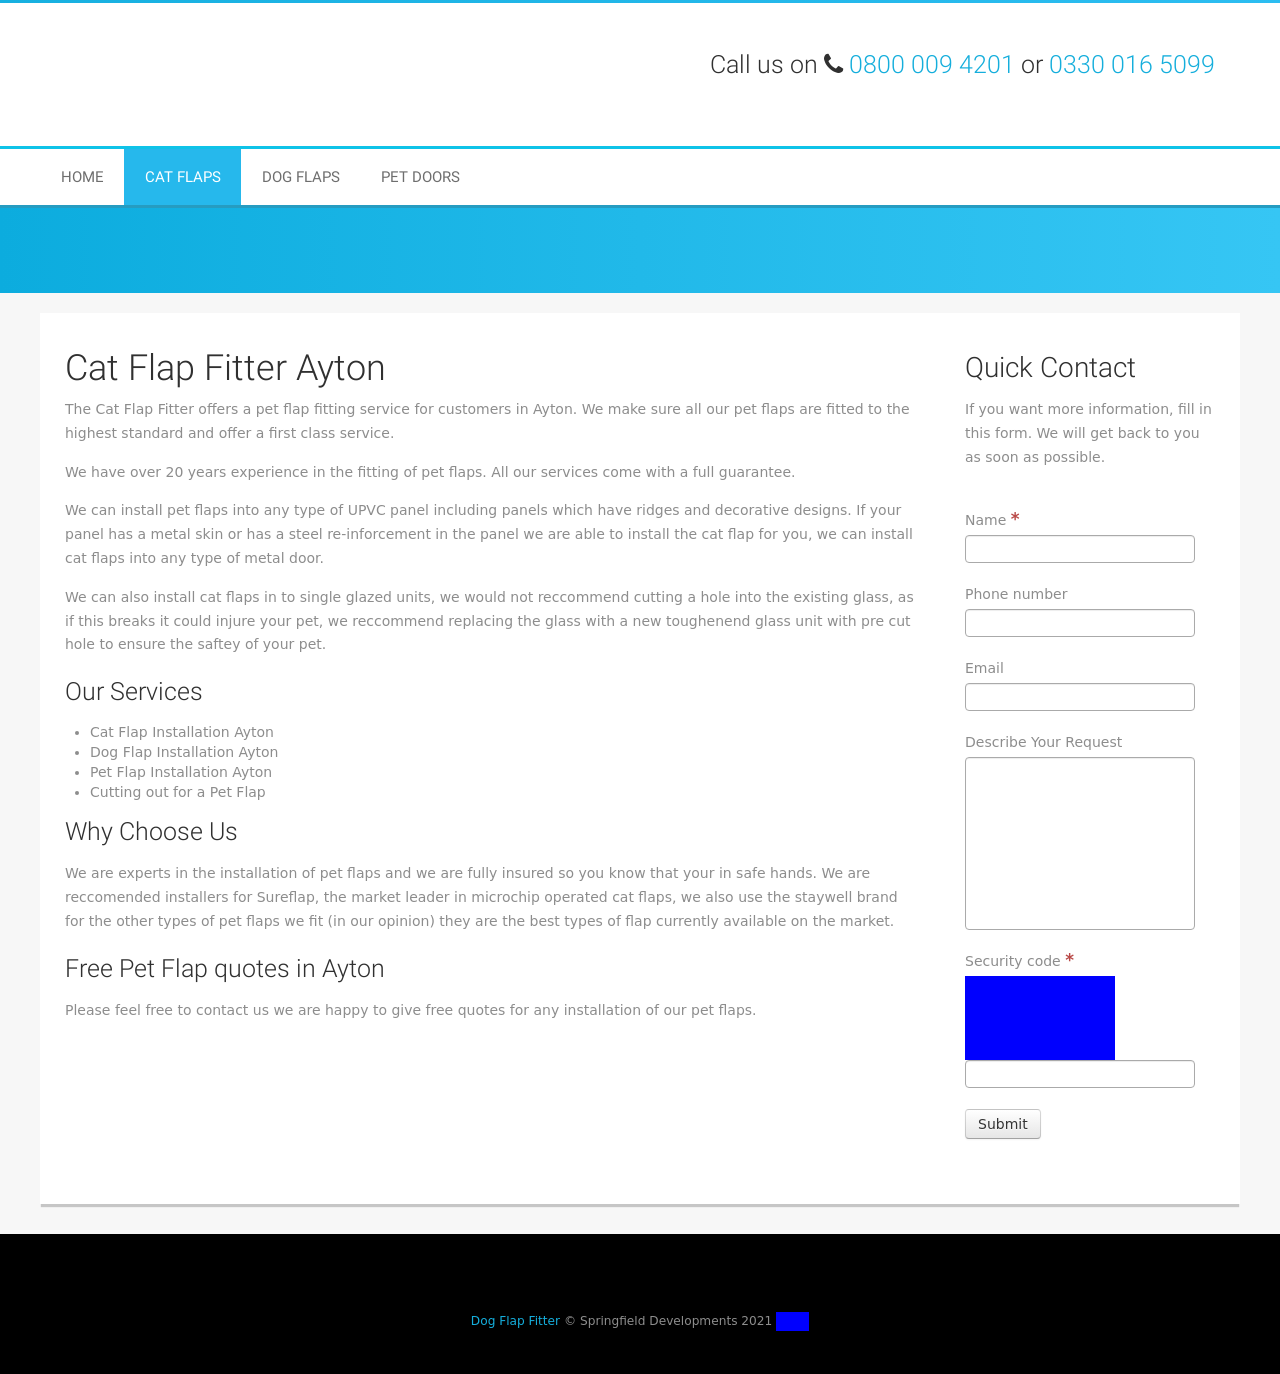Can you explain why using toughened glass is recommended for pet flap installations? Using toughened glass for pet flap installations is recommended because it enhances safety. Cutting holes in existing glass can weaken it and risk breakage, which could potentially harm the pet. Toughened glass is stronger and reduces the risk of breakage, providing a safer exit and entry point for pets. Is there an alternative to toughened glass that can also be used? An alternative to toughened glass could be laminated glass, which also offers increased durability and safety. Laminated glass holds together when shattered, reducing the risk of injuries to pets from broken sharp edges. 